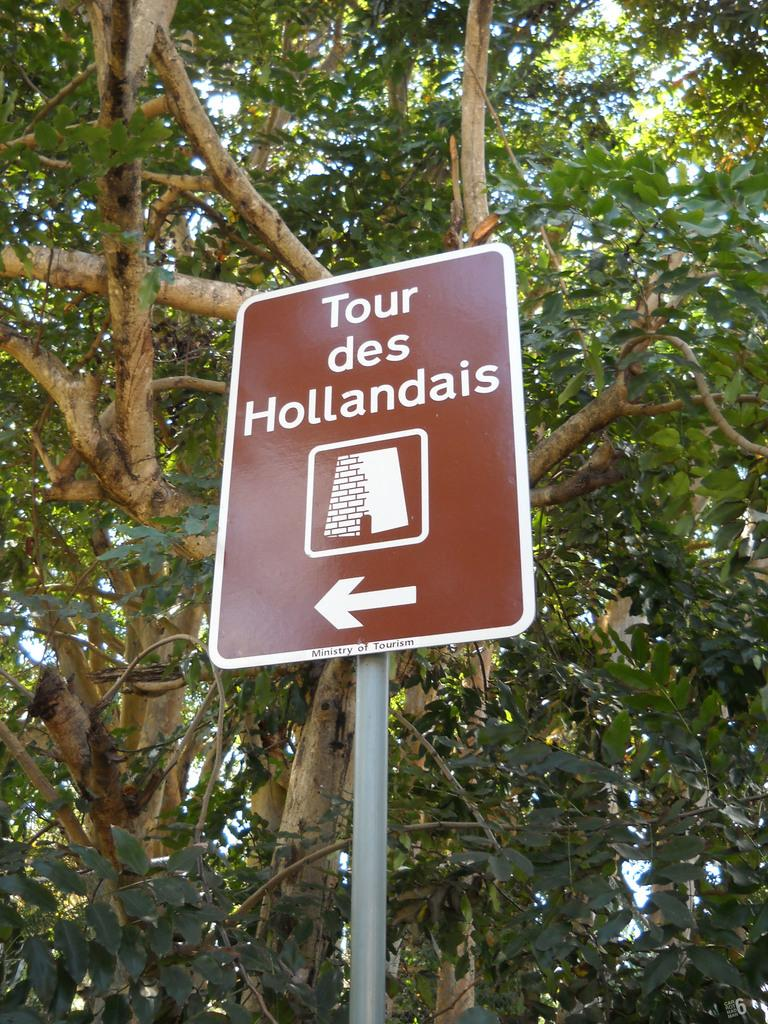What is the main object in the image? There is a sign board in the image. What information is displayed on the sign board? The sign board has text and an image on it. What direction is indicated by the sign board? The sign board has an arrow mark on it. What can be seen in the background of the image? There is a tree behind the sign board. How many minutes does it take for the orange to ripen in the image? There is no orange present in the image, so it is not possible to determine how long it would take to ripen. 